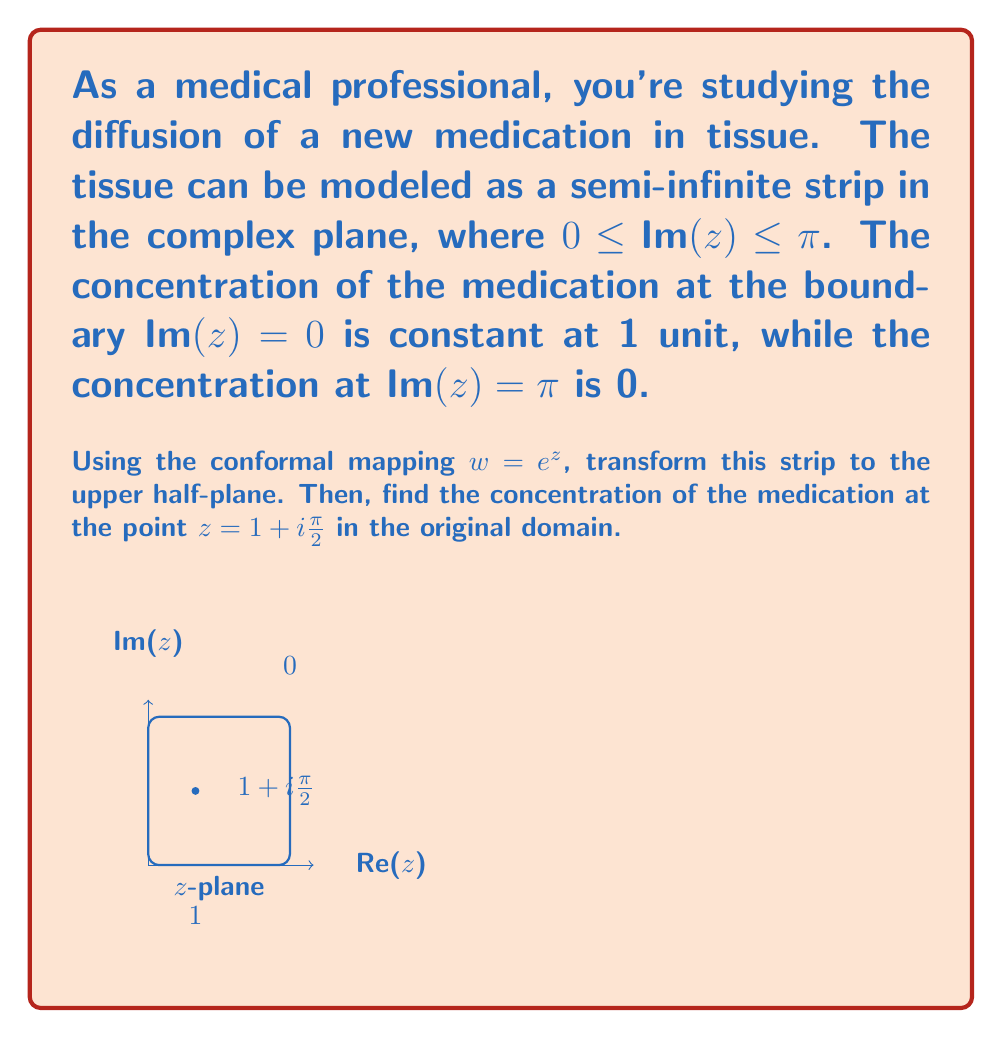Teach me how to tackle this problem. Let's approach this step-by-step:

1) The conformal mapping $w = e^z$ transforms the strip $0 \leq \text{Im}(z) \leq \pi$ in the $z$-plane to the upper half-plane in the $w$-plane.

2) In the $w$-plane, the boundary $\text{Im}(z) = 0$ maps to the positive real axis, and $\text{Im}(z) = \pi$ maps to the negative real axis.

3) The concentration in the $w$-plane can be described by the function:

   $$u(w) = \frac{1}{\pi} \arg(w)$$

   where $\arg(w)$ is the argument of $w$ in radians.

4) To find the concentration at $z = 1 + i\frac{\pi}{2}$, we need to map this point to the $w$-plane:

   $$w = e^{1 + i\frac{\pi}{2}} = e^1 \cdot e^{i\frac{\pi}{2}} = e \cdot i = i \cdot e$$

5) Now, we can calculate the concentration:

   $$u(w) = \frac{1}{\pi} \arg(ie) = \frac{1}{\pi} \cdot \frac{\pi}{2} = \frac{1}{2}$$

Therefore, the concentration of the medication at the point $z = 1 + i\frac{\pi}{2}$ in the original domain is 0.5 units.
Answer: $\frac{1}{2}$ 